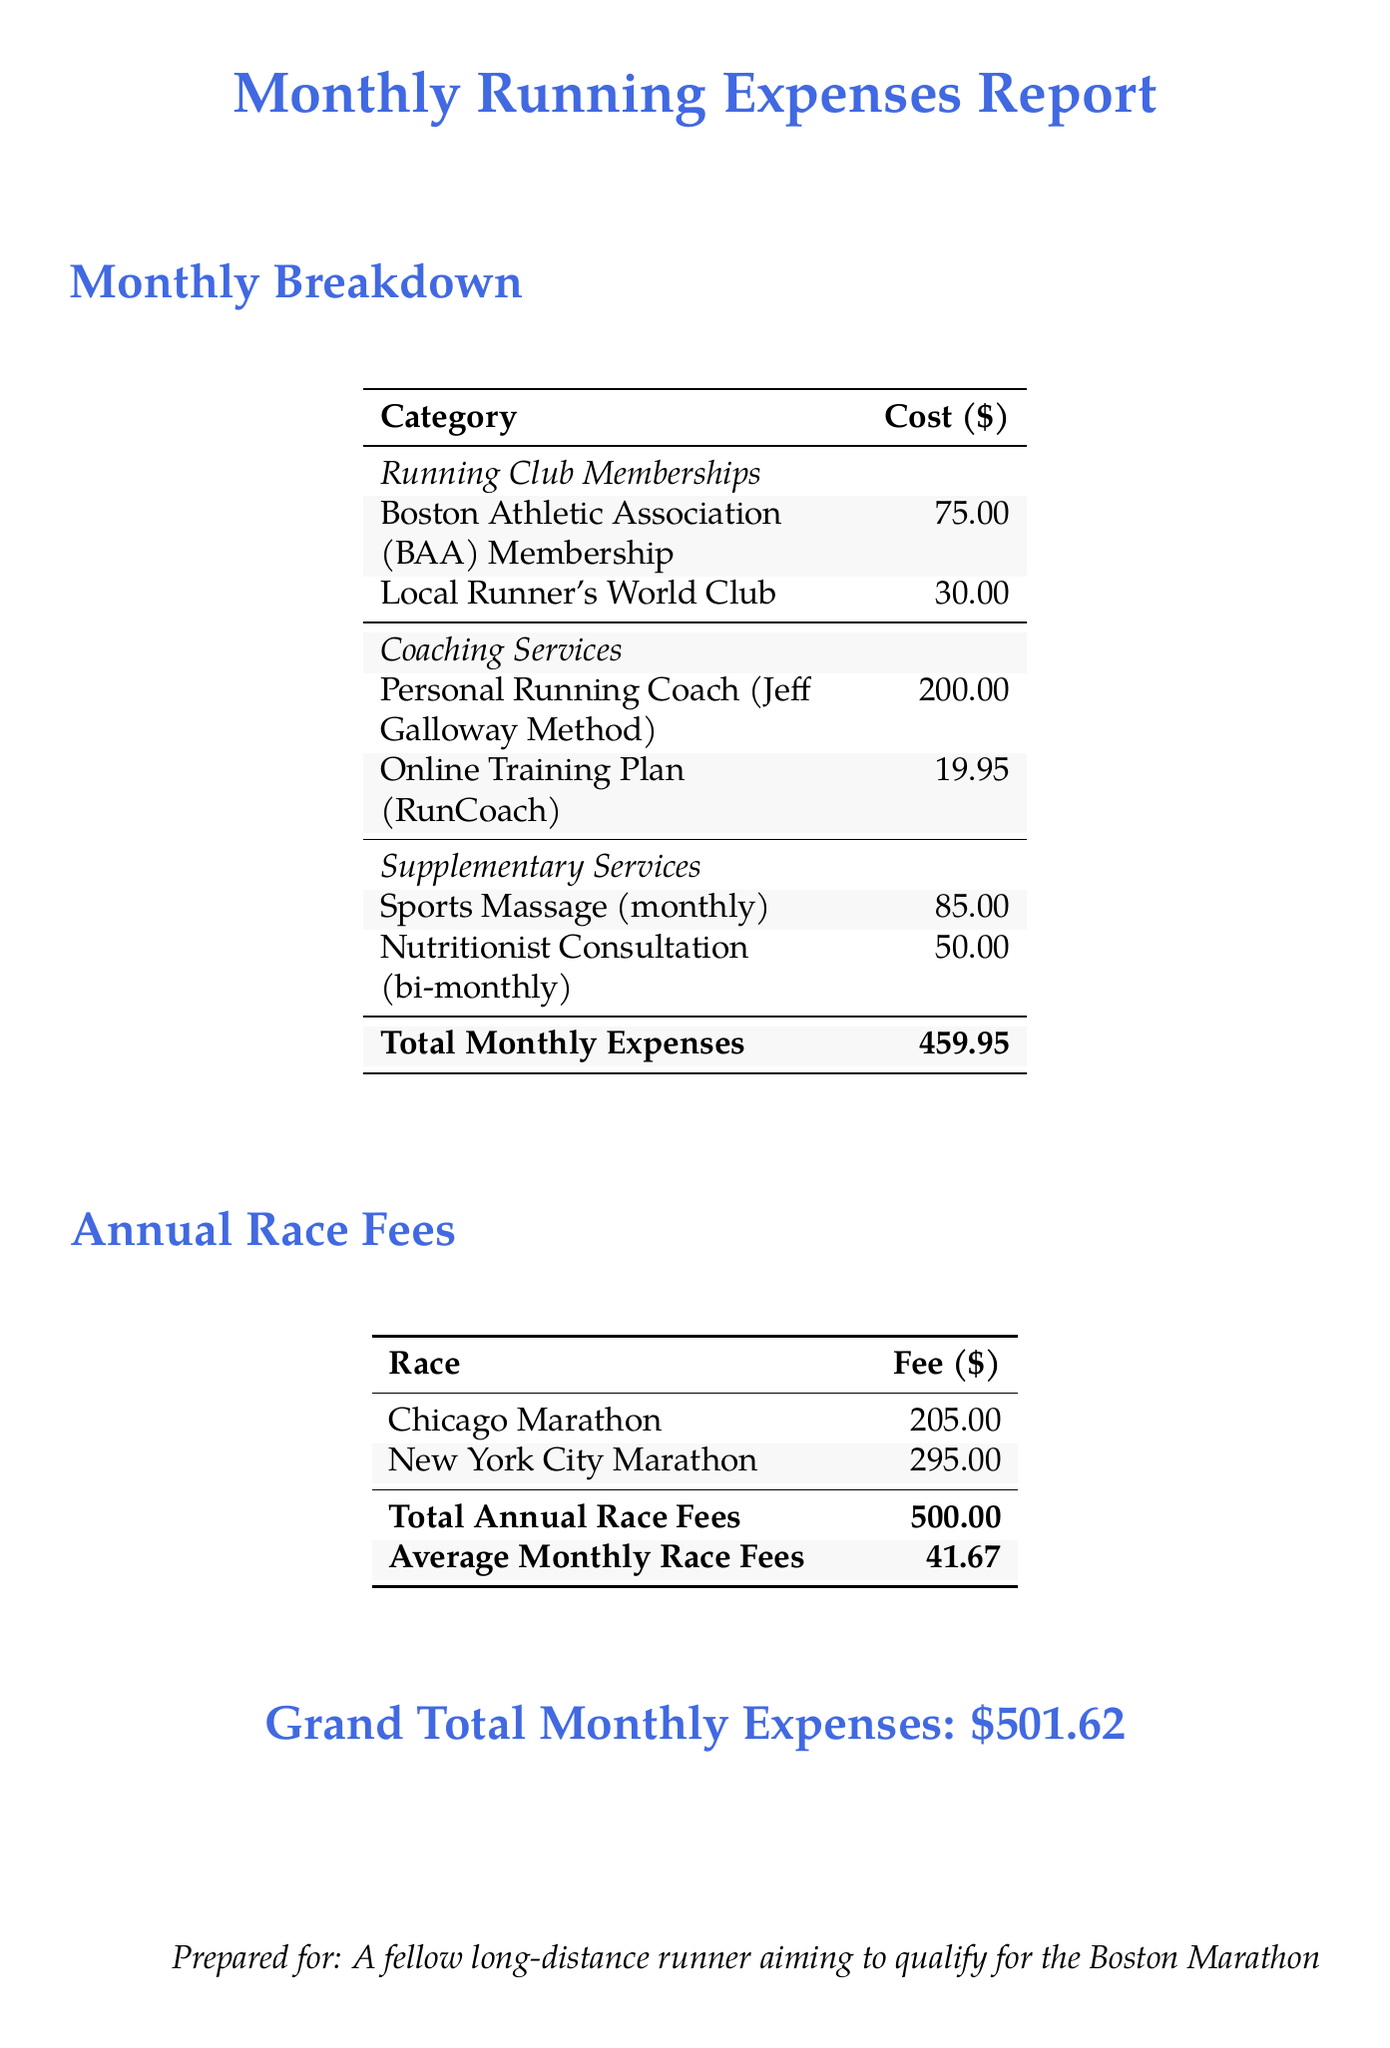What are the total monthly expenses? The total monthly expenses are explicitly stated in the document as a summary.
Answer: 459.95 How much does the Personal Running Coach cost? The cost of the Personal Running Coach is listed under Coaching Services in the document.
Answer: 200.00 What is the fee for the New York City Marathon? The fee for the New York City Marathon is mentioned in the Annual Race Fees section of the document.
Answer: 295.00 What is the average monthly race fee? The average monthly race fee is calculated based on the total annual race fees divided by 12 months.
Answer: 41.67 How much is spent on Sports Massage monthly? The cost for Sports Massage is mentioned under Supplementary Services in the document.
Answer: 85.00 What is the grand total monthly expense? The grand total monthly expense is presented at the bottom of the document summarizing all expenses.
Answer: 501.62 How many memberships are listed under Running Club Memberships? The document specifies all memberships in the Running Club Memberships category, allowing for a count.
Answer: 2 How much do you pay for Nutritionist Consultation bi-monthly? The cost for Nutritionist Consultation is provided, indicating the expense every two months clearly mentioned.
Answer: 50.00 What document is this summary prepared for? The last line of the document states the intended audience clearly.
Answer: A fellow long-distance runner aiming to qualify for the Boston Marathon 